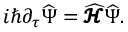Convert formula to latex. <formula><loc_0><loc_0><loc_500><loc_500>i \hbar { \partial } _ { \tau } { \widehat { \Psi } } = { \widehat { \pm b { \ m a t h s c r { H } } } } { \widehat { \Psi } } .</formula> 